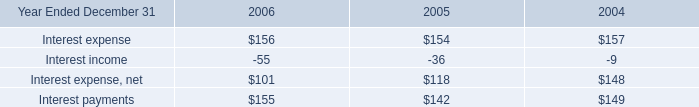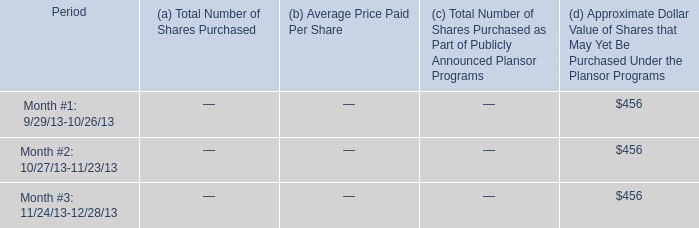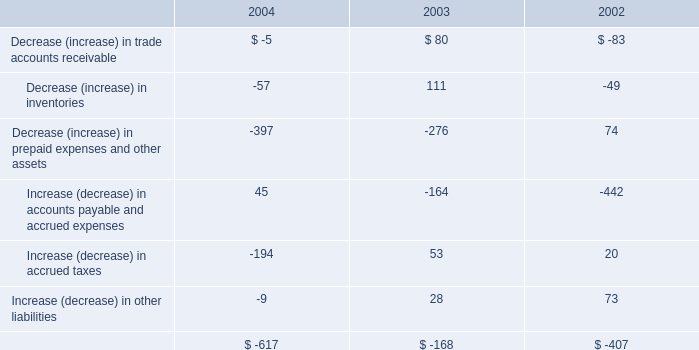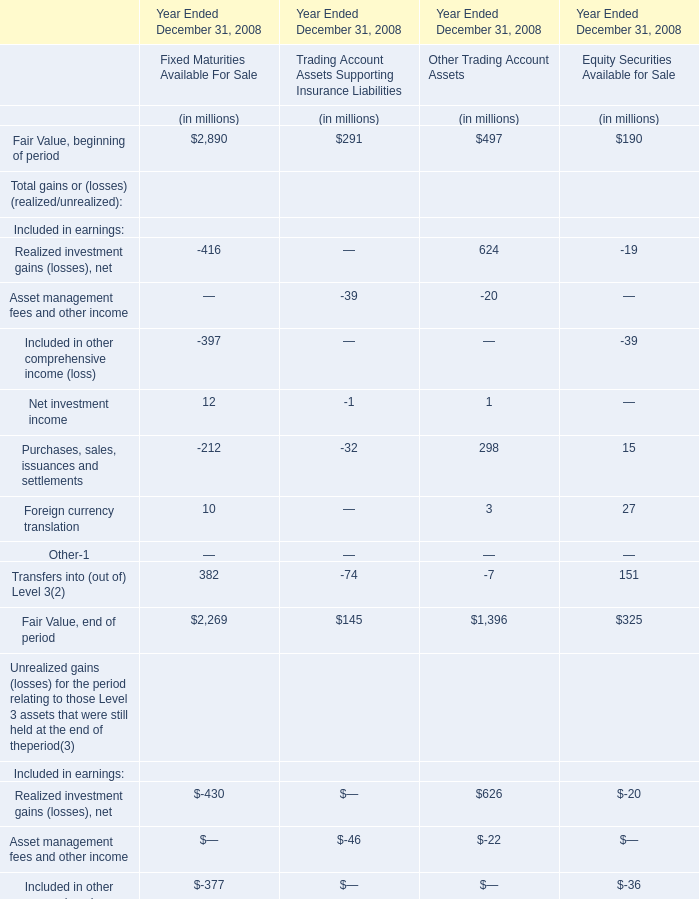Does the value of Fair Value, beginning of period for Trading Account Assets Supporting Insurance Liabilities greater than that inFixed Maturities Available For Sale ? 
Answer: no. 